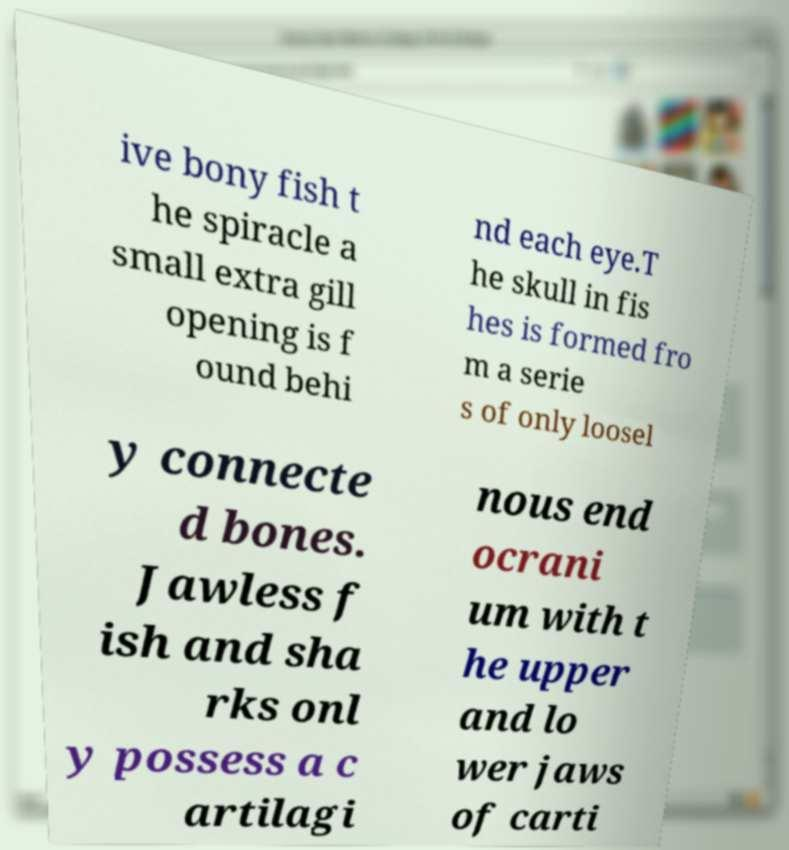What messages or text are displayed in this image? I need them in a readable, typed format. ive bony fish t he spiracle a small extra gill opening is f ound behi nd each eye.T he skull in fis hes is formed fro m a serie s of only loosel y connecte d bones. Jawless f ish and sha rks onl y possess a c artilagi nous end ocrani um with t he upper and lo wer jaws of carti 